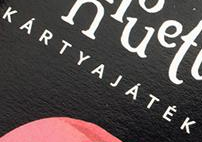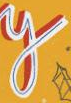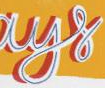What text is displayed in these images sequentially, separated by a semicolon? KÁRTYAJÁTÉK; y; ays 